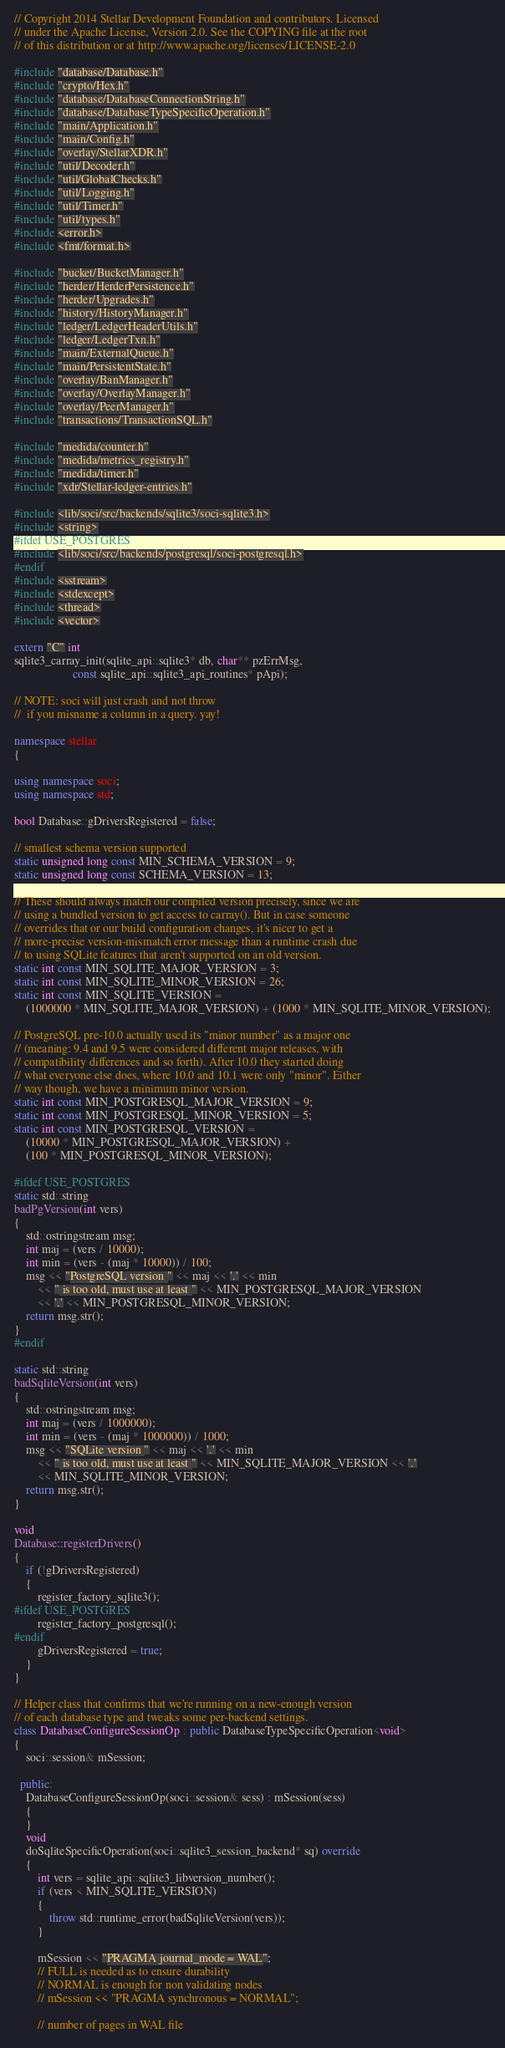<code> <loc_0><loc_0><loc_500><loc_500><_C++_>// Copyright 2014 Stellar Development Foundation and contributors. Licensed
// under the Apache License, Version 2.0. See the COPYING file at the root
// of this distribution or at http://www.apache.org/licenses/LICENSE-2.0

#include "database/Database.h"
#include "crypto/Hex.h"
#include "database/DatabaseConnectionString.h"
#include "database/DatabaseTypeSpecificOperation.h"
#include "main/Application.h"
#include "main/Config.h"
#include "overlay/StellarXDR.h"
#include "util/Decoder.h"
#include "util/GlobalChecks.h"
#include "util/Logging.h"
#include "util/Timer.h"
#include "util/types.h"
#include <error.h>
#include <fmt/format.h>

#include "bucket/BucketManager.h"
#include "herder/HerderPersistence.h"
#include "herder/Upgrades.h"
#include "history/HistoryManager.h"
#include "ledger/LedgerHeaderUtils.h"
#include "ledger/LedgerTxn.h"
#include "main/ExternalQueue.h"
#include "main/PersistentState.h"
#include "overlay/BanManager.h"
#include "overlay/OverlayManager.h"
#include "overlay/PeerManager.h"
#include "transactions/TransactionSQL.h"

#include "medida/counter.h"
#include "medida/metrics_registry.h"
#include "medida/timer.h"
#include "xdr/Stellar-ledger-entries.h"

#include <lib/soci/src/backends/sqlite3/soci-sqlite3.h>
#include <string>
#ifdef USE_POSTGRES
#include <lib/soci/src/backends/postgresql/soci-postgresql.h>
#endif
#include <sstream>
#include <stdexcept>
#include <thread>
#include <vector>

extern "C" int
sqlite3_carray_init(sqlite_api::sqlite3* db, char** pzErrMsg,
                    const sqlite_api::sqlite3_api_routines* pApi);

// NOTE: soci will just crash and not throw
//  if you misname a column in a query. yay!

namespace stellar
{

using namespace soci;
using namespace std;

bool Database::gDriversRegistered = false;

// smallest schema version supported
static unsigned long const MIN_SCHEMA_VERSION = 9;
static unsigned long const SCHEMA_VERSION = 13;

// These should always match our compiled version precisely, since we are
// using a bundled version to get access to carray(). But in case someone
// overrides that or our build configuration changes, it's nicer to get a
// more-precise version-mismatch error message than a runtime crash due
// to using SQLite features that aren't supported on an old version.
static int const MIN_SQLITE_MAJOR_VERSION = 3;
static int const MIN_SQLITE_MINOR_VERSION = 26;
static int const MIN_SQLITE_VERSION =
    (1000000 * MIN_SQLITE_MAJOR_VERSION) + (1000 * MIN_SQLITE_MINOR_VERSION);

// PostgreSQL pre-10.0 actually used its "minor number" as a major one
// (meaning: 9.4 and 9.5 were considered different major releases, with
// compatibility differences and so forth). After 10.0 they started doing
// what everyone else does, where 10.0 and 10.1 were only "minor". Either
// way though, we have a minimum minor version.
static int const MIN_POSTGRESQL_MAJOR_VERSION = 9;
static int const MIN_POSTGRESQL_MINOR_VERSION = 5;
static int const MIN_POSTGRESQL_VERSION =
    (10000 * MIN_POSTGRESQL_MAJOR_VERSION) +
    (100 * MIN_POSTGRESQL_MINOR_VERSION);

#ifdef USE_POSTGRES
static std::string
badPgVersion(int vers)
{
    std::ostringstream msg;
    int maj = (vers / 10000);
    int min = (vers - (maj * 10000)) / 100;
    msg << "PostgreSQL version " << maj << '.' << min
        << " is too old, must use at least " << MIN_POSTGRESQL_MAJOR_VERSION
        << '.' << MIN_POSTGRESQL_MINOR_VERSION;
    return msg.str();
}
#endif

static std::string
badSqliteVersion(int vers)
{
    std::ostringstream msg;
    int maj = (vers / 1000000);
    int min = (vers - (maj * 1000000)) / 1000;
    msg << "SQLite version " << maj << '.' << min
        << " is too old, must use at least " << MIN_SQLITE_MAJOR_VERSION << '.'
        << MIN_SQLITE_MINOR_VERSION;
    return msg.str();
}

void
Database::registerDrivers()
{
    if (!gDriversRegistered)
    {
        register_factory_sqlite3();
#ifdef USE_POSTGRES
        register_factory_postgresql();
#endif
        gDriversRegistered = true;
    }
}

// Helper class that confirms that we're running on a new-enough version
// of each database type and tweaks some per-backend settings.
class DatabaseConfigureSessionOp : public DatabaseTypeSpecificOperation<void>
{
    soci::session& mSession;

  public:
    DatabaseConfigureSessionOp(soci::session& sess) : mSession(sess)
    {
    }
    void
    doSqliteSpecificOperation(soci::sqlite3_session_backend* sq) override
    {
        int vers = sqlite_api::sqlite3_libversion_number();
        if (vers < MIN_SQLITE_VERSION)
        {
            throw std::runtime_error(badSqliteVersion(vers));
        }

        mSession << "PRAGMA journal_mode = WAL";
        // FULL is needed as to ensure durability
        // NORMAL is enough for non validating nodes
        // mSession << "PRAGMA synchronous = NORMAL";

        // number of pages in WAL file</code> 